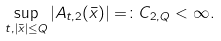<formula> <loc_0><loc_0><loc_500><loc_500>\sup _ { t , | \bar { x } | \leq Q } | A _ { t , 2 } ( \bar { x } ) | = \colon C _ { 2 , Q } < \infty .</formula> 